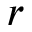<formula> <loc_0><loc_0><loc_500><loc_500>r</formula> 